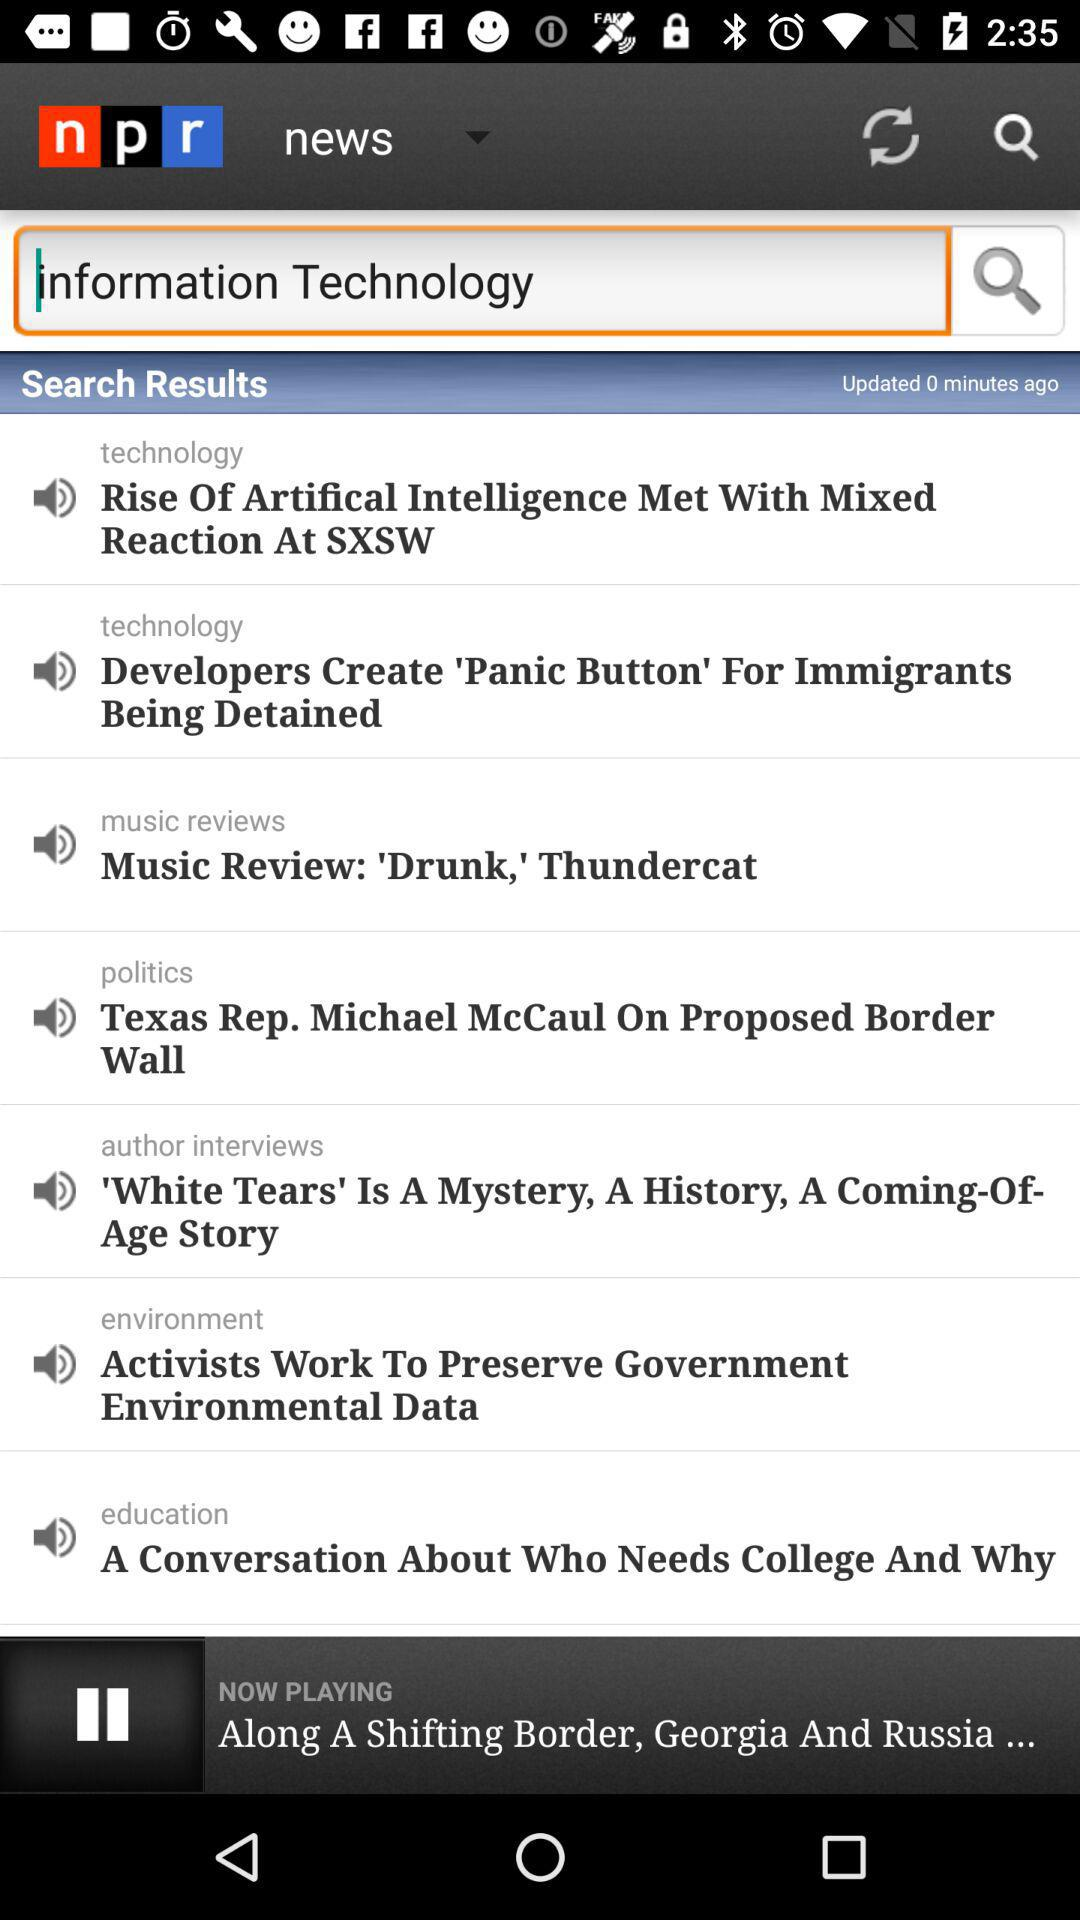Who worked to preserve government environmental data? To preserve government environmental data, the "Activists" are working. 